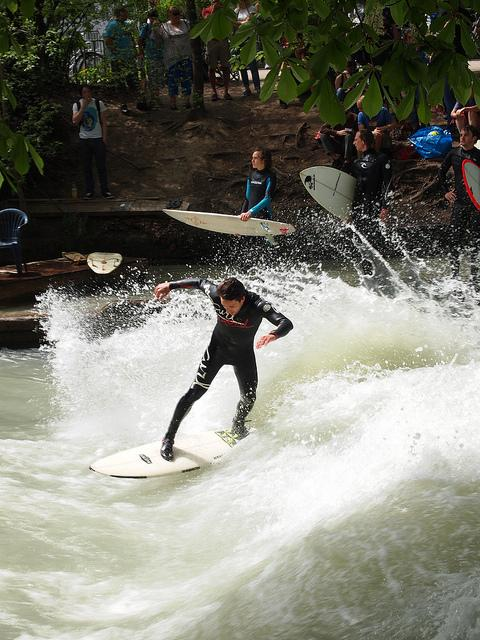Why is he standing like that? Please explain your reasoning. maintain balance. The man doesn't want to fall. 